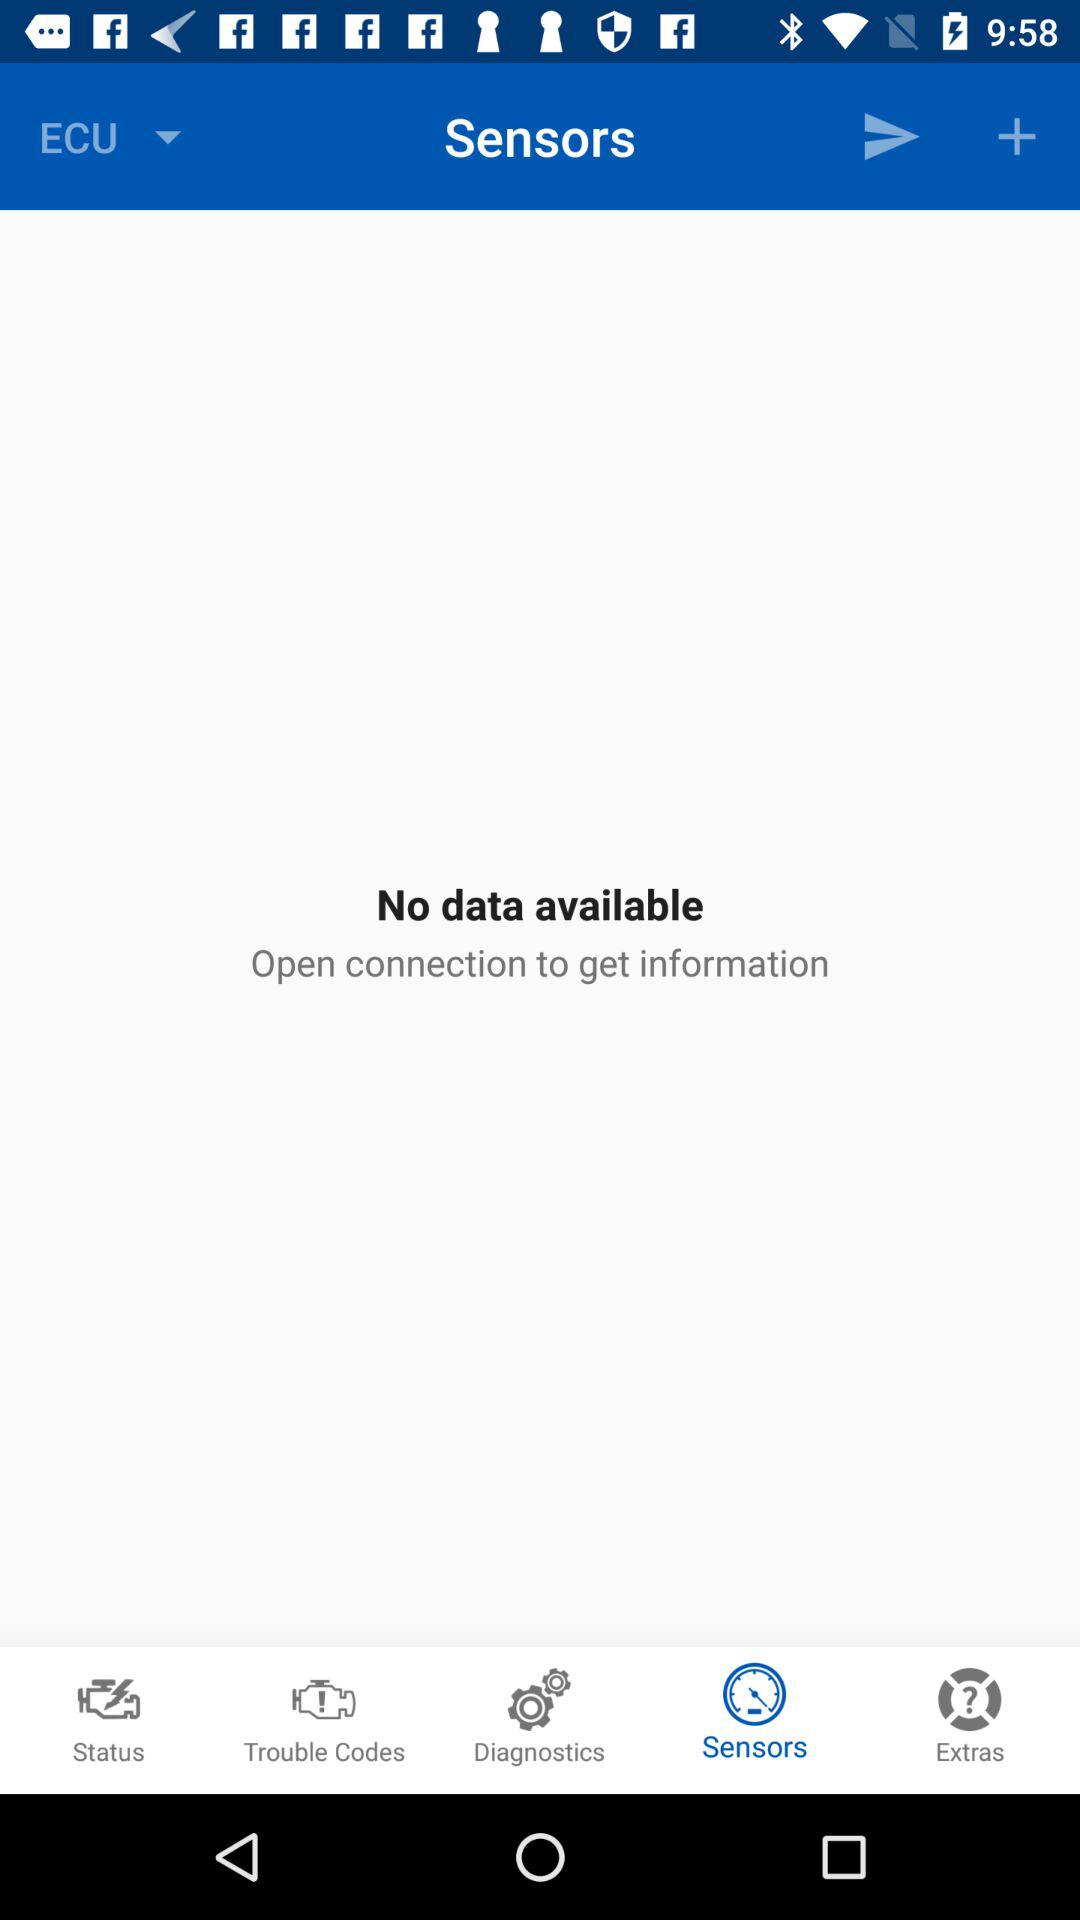Which tab has been selected? The selected tab is "Sensors". 